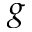<formula> <loc_0><loc_0><loc_500><loc_500>g</formula> 